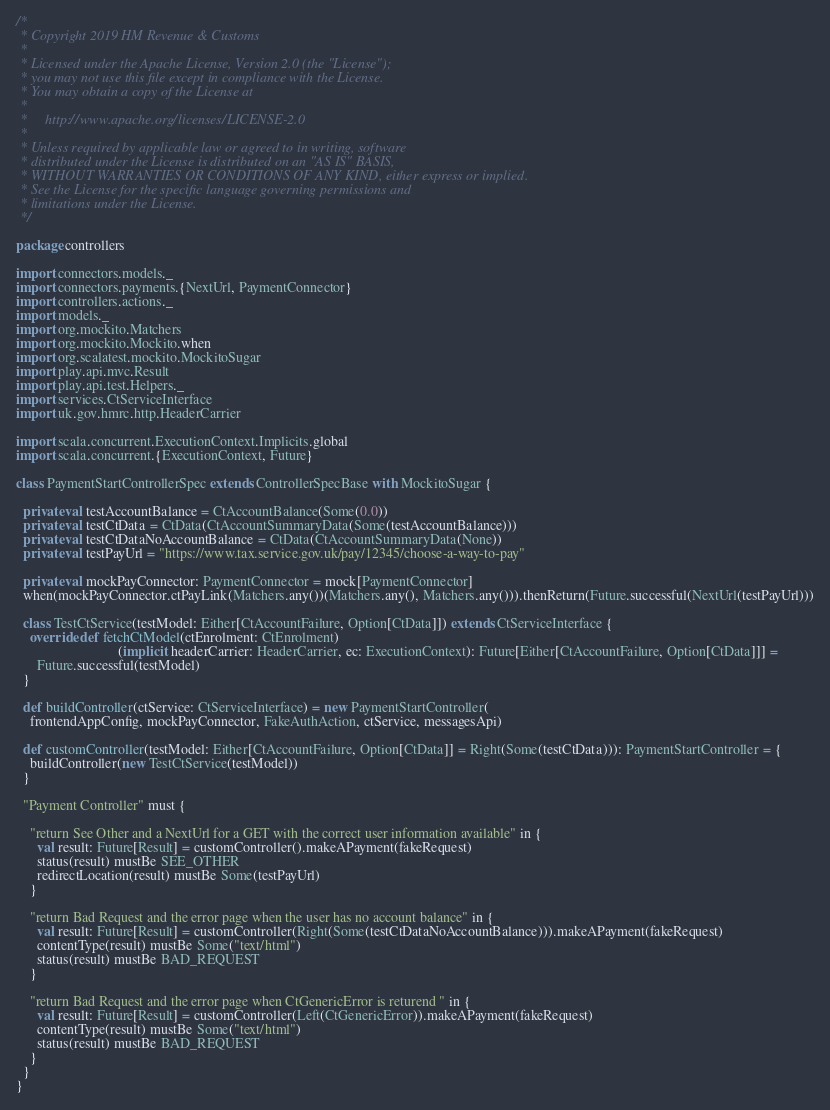<code> <loc_0><loc_0><loc_500><loc_500><_Scala_>/*
 * Copyright 2019 HM Revenue & Customs
 *
 * Licensed under the Apache License, Version 2.0 (the "License");
 * you may not use this file except in compliance with the License.
 * You may obtain a copy of the License at
 *
 *     http://www.apache.org/licenses/LICENSE-2.0
 *
 * Unless required by applicable law or agreed to in writing, software
 * distributed under the License is distributed on an "AS IS" BASIS,
 * WITHOUT WARRANTIES OR CONDITIONS OF ANY KIND, either express or implied.
 * See the License for the specific language governing permissions and
 * limitations under the License.
 */

package controllers

import connectors.models._
import connectors.payments.{NextUrl, PaymentConnector}
import controllers.actions._
import models._
import org.mockito.Matchers
import org.mockito.Mockito.when
import org.scalatest.mockito.MockitoSugar
import play.api.mvc.Result
import play.api.test.Helpers._
import services.CtServiceInterface
import uk.gov.hmrc.http.HeaderCarrier

import scala.concurrent.ExecutionContext.Implicits.global
import scala.concurrent.{ExecutionContext, Future}

class PaymentStartControllerSpec extends ControllerSpecBase with MockitoSugar {

  private val testAccountBalance = CtAccountBalance(Some(0.0))
  private val testCtData = CtData(CtAccountSummaryData(Some(testAccountBalance)))
  private val testCtDataNoAccountBalance = CtData(CtAccountSummaryData(None))
  private val testPayUrl = "https://www.tax.service.gov.uk/pay/12345/choose-a-way-to-pay"

  private val mockPayConnector: PaymentConnector = mock[PaymentConnector]
  when(mockPayConnector.ctPayLink(Matchers.any())(Matchers.any(), Matchers.any())).thenReturn(Future.successful(NextUrl(testPayUrl)))

  class TestCtService(testModel: Either[CtAccountFailure, Option[CtData]]) extends CtServiceInterface {
    override def fetchCtModel(ctEnrolment: CtEnrolment)
                             (implicit headerCarrier: HeaderCarrier, ec: ExecutionContext): Future[Either[CtAccountFailure, Option[CtData]]] =
      Future.successful(testModel)
  }

  def buildController(ctService: CtServiceInterface) = new PaymentStartController(
    frontendAppConfig, mockPayConnector, FakeAuthAction, ctService, messagesApi)

  def customController(testModel: Either[CtAccountFailure, Option[CtData]] = Right(Some(testCtData))): PaymentStartController = {
    buildController(new TestCtService(testModel))
  }

  "Payment Controller" must {

    "return See Other and a NextUrl for a GET with the correct user information available" in {
      val result: Future[Result] = customController().makeAPayment(fakeRequest)
      status(result) mustBe SEE_OTHER
      redirectLocation(result) mustBe Some(testPayUrl)
    }

    "return Bad Request and the error page when the user has no account balance" in {
      val result: Future[Result] = customController(Right(Some(testCtDataNoAccountBalance))).makeAPayment(fakeRequest)
      contentType(result) mustBe Some("text/html")
      status(result) mustBe BAD_REQUEST
    }

    "return Bad Request and the error page when CtGenericError is returend " in {
      val result: Future[Result] = customController(Left(CtGenericError)).makeAPayment(fakeRequest)
      contentType(result) mustBe Some("text/html")
      status(result) mustBe BAD_REQUEST
    }
  }
}
</code> 